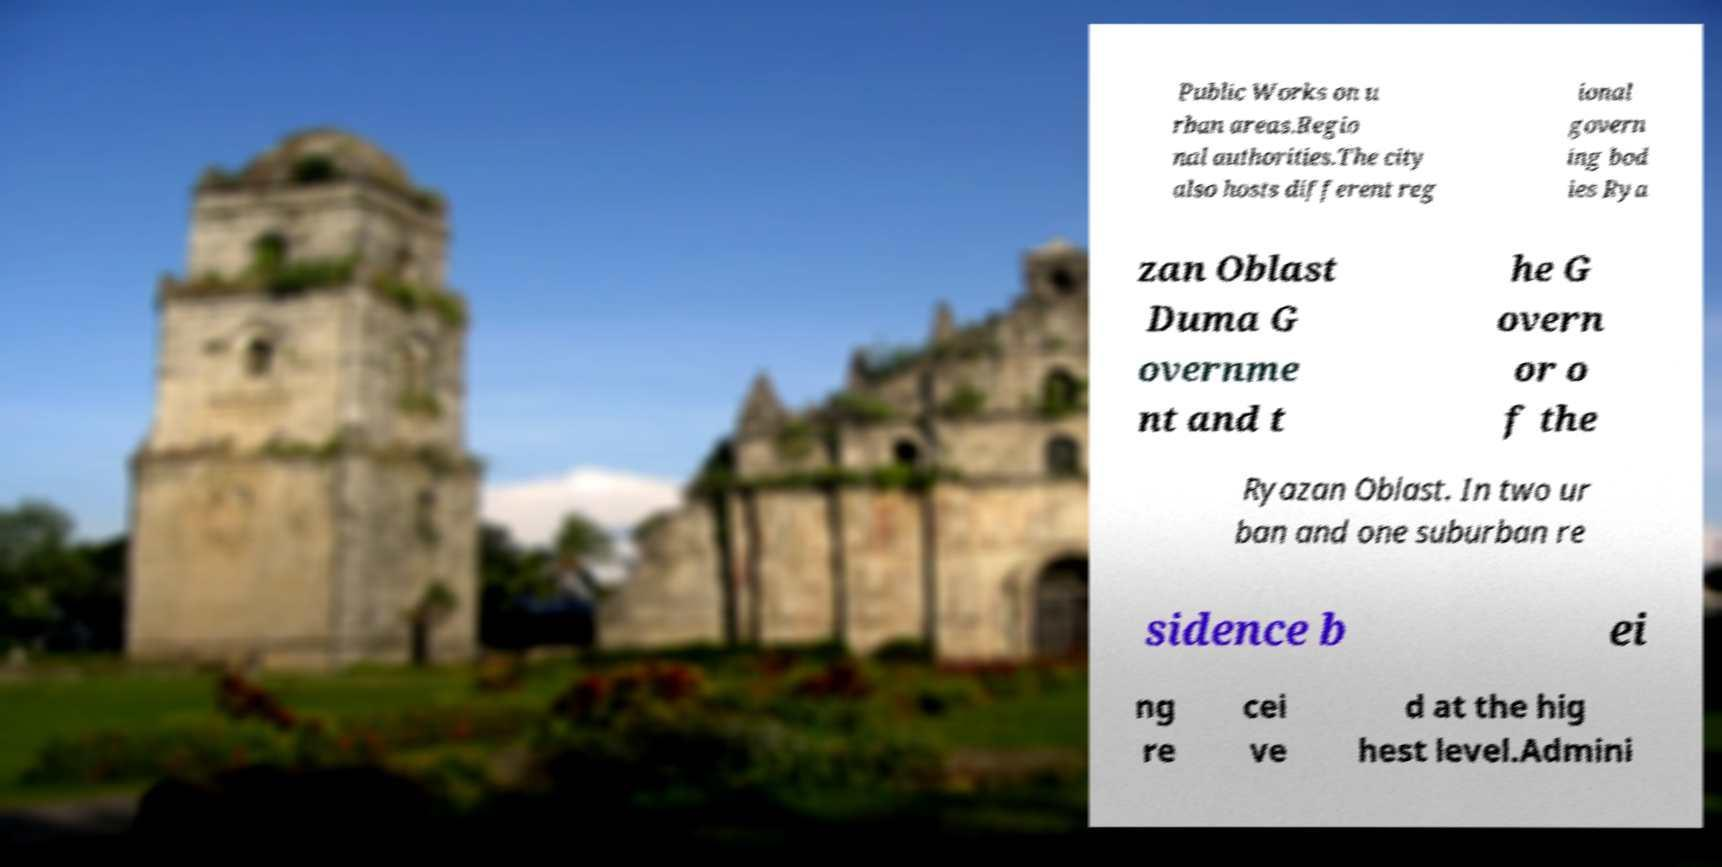Please identify and transcribe the text found in this image. Public Works on u rban areas.Regio nal authorities.The city also hosts different reg ional govern ing bod ies Rya zan Oblast Duma G overnme nt and t he G overn or o f the Ryazan Oblast. In two ur ban and one suburban re sidence b ei ng re cei ve d at the hig hest level.Admini 